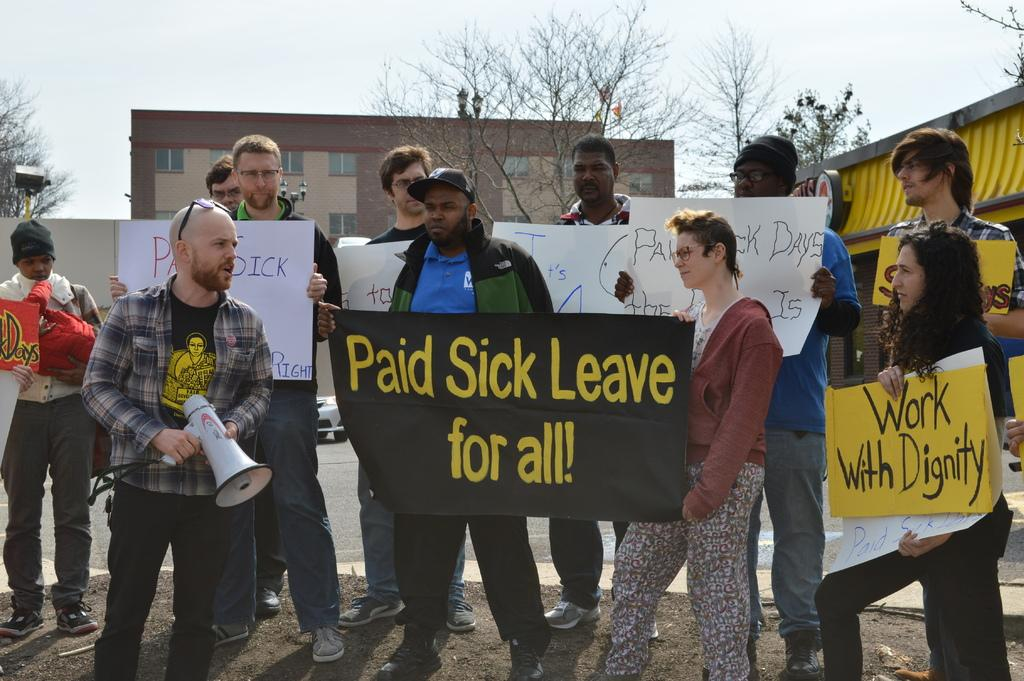How many people are in the image? There is a group of people in the image, but the exact number is not specified. What are the people holding in the image? The people are holding boards in the image. Can you describe any additional objects held by the people? One person is holding a megaphone in the image. What can be seen in the background of the image? There are trees, buildings, and the sky visible in the background of the image. Where is the nest located in the image? There is no nest present in the image. Can you see the moon in the image? The sky is visible in the background of the image, but there is no indication of the moon being present. 